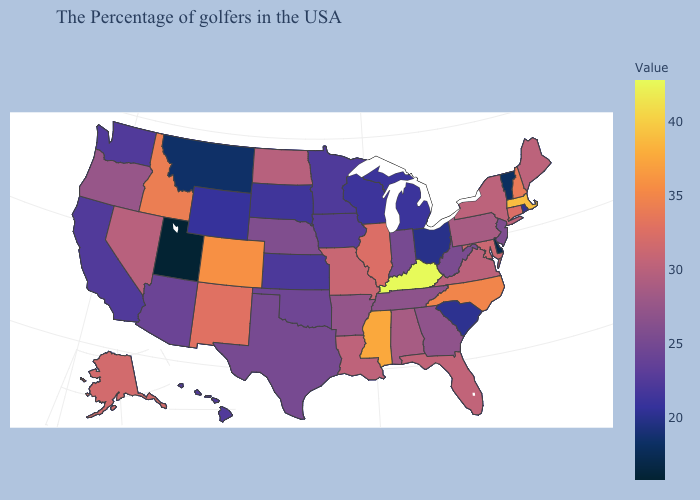Does the map have missing data?
Be succinct. No. Does the map have missing data?
Quick response, please. No. Among the states that border Texas , does Louisiana have the lowest value?
Be succinct. No. Among the states that border New Hampshire , does Vermont have the lowest value?
Be succinct. Yes. Which states have the lowest value in the West?
Short answer required. Utah. 